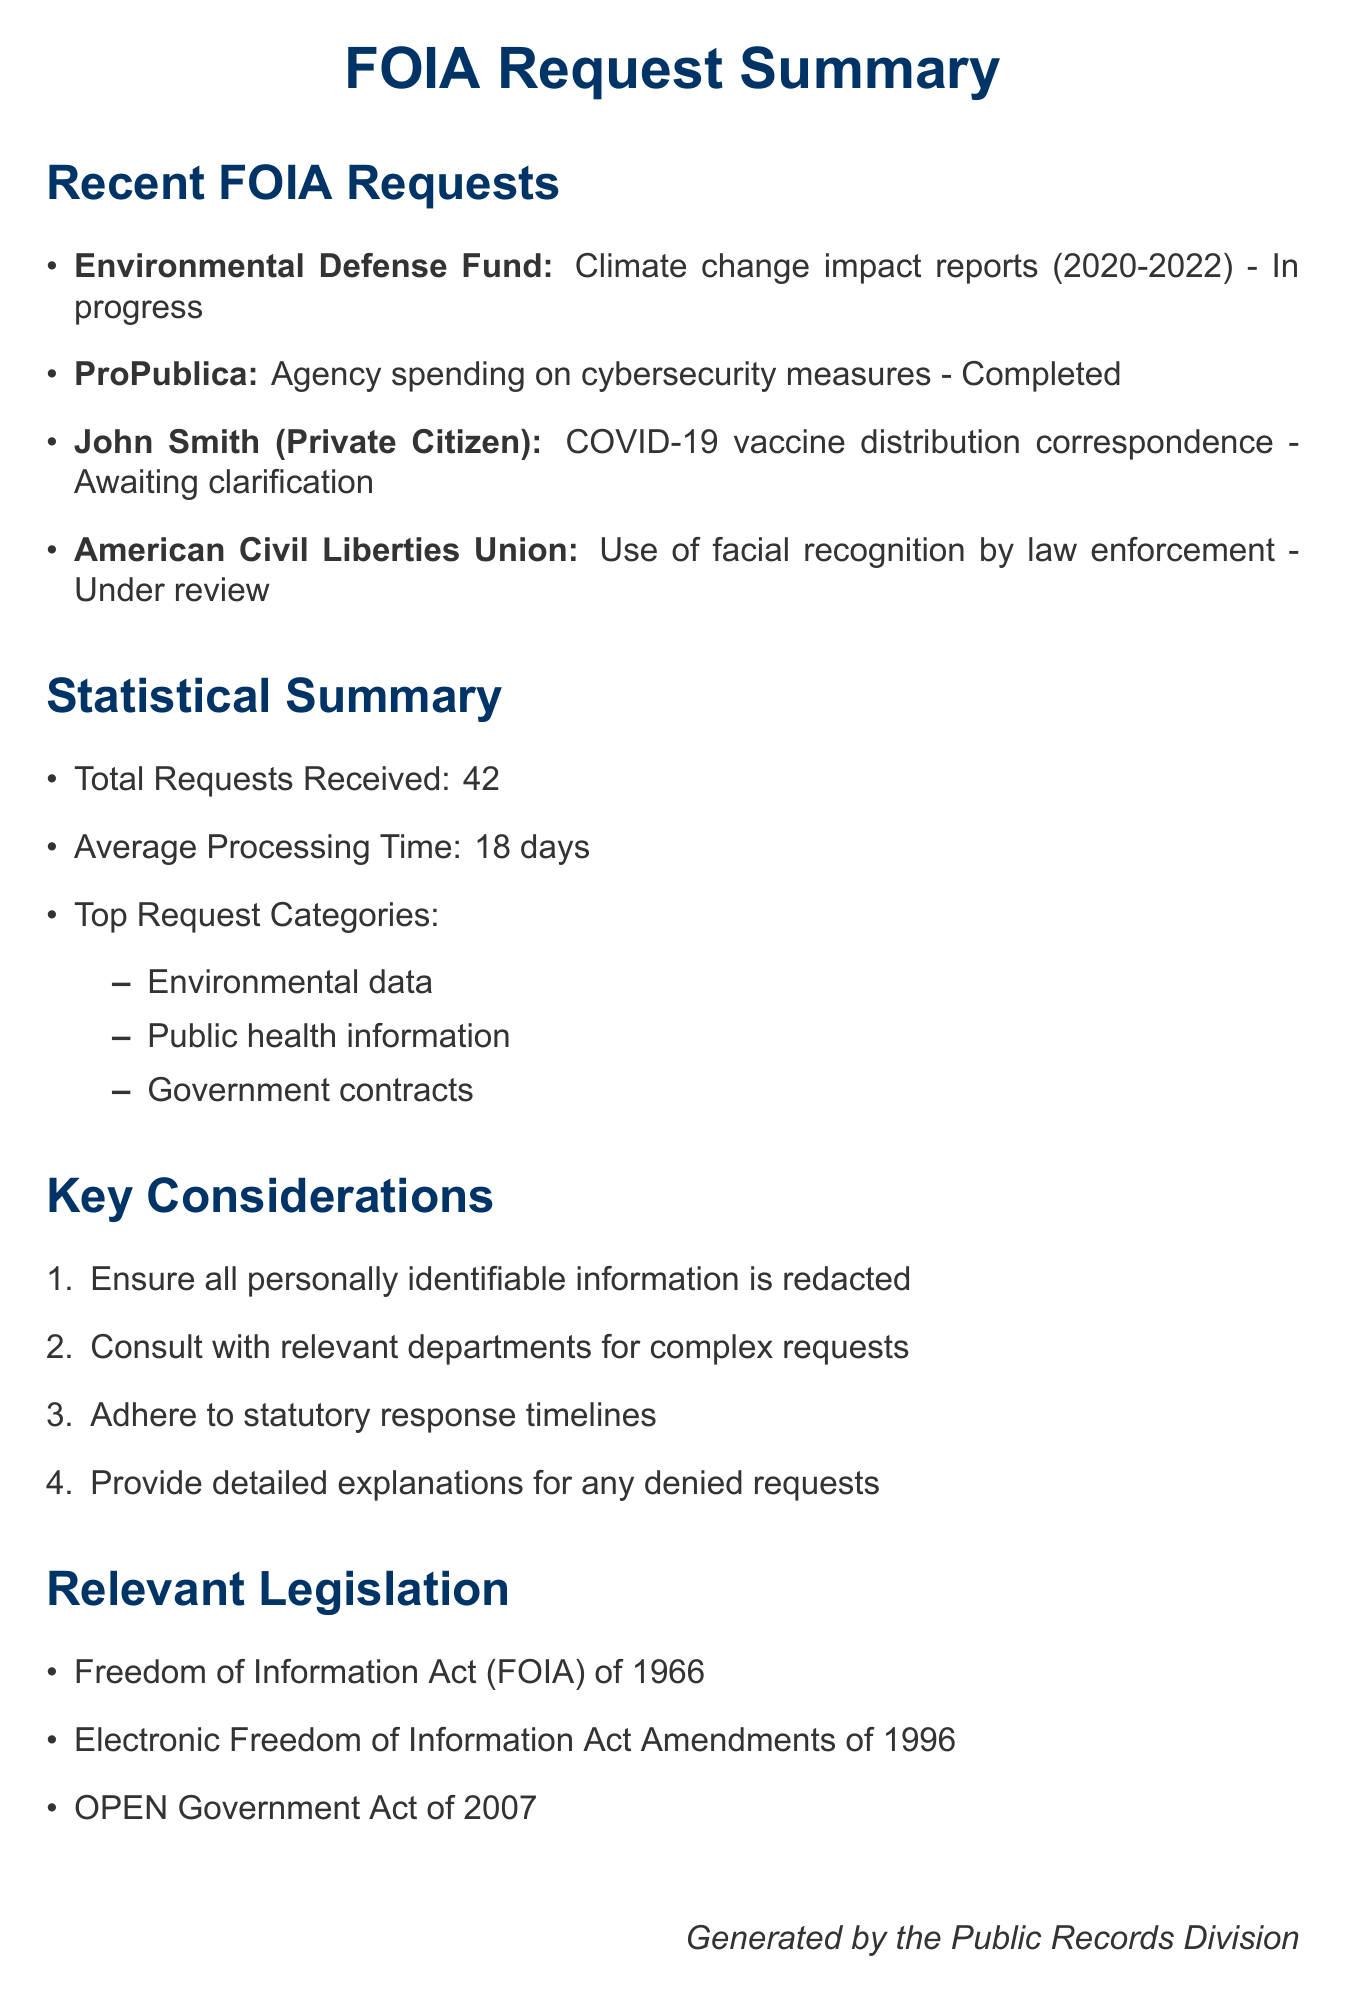What is the requestor for the climate change impact reports? The requestor is clearly stated in the document as the Environmental Defense Fund, seeking specific impact reports.
Answer: Environmental Defense Fund What is the nature of the request from ProPublica? The document specifies that ProPublica requested information regarding agency spending on cybersecurity measures.
Answer: Agency spending on cybersecurity measures What is the status of John Smith's request? The status of John Smith's request is clearly indicated in the document as awaiting clarification.
Answer: Awaiting clarification How many total FOIA requests have been received? The document provides the total number of requests received, which is a specific numeric value.
Answer: 42 What is the average processing time for FOIA requests? The document includes the average processing time, which is detailed as a specific number of days.
Answer: 18 days Which organization requested information on facial recognition technology? The document identifies the organization making the request related to facial recognition technology.
Answer: American Civil Liberties Union What is one of the top request categories mentioned? The document lists categories of requests, requiring knowledge of the content to identify one.
Answer: Environmental data What should be ensured regarding personally identifiable information? The document specifically states the principle regarding personally identifiable information handling.
Answer: Redacted Which Act is relevant legislation mentioned in the document? The document refers to specific legislation, requiring familiarity with its titles for identification.
Answer: Freedom of Information Act (FOIA) of 1966 